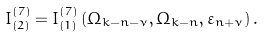<formula> <loc_0><loc_0><loc_500><loc_500>I _ { \left ( 2 \right ) } ^ { ( 7 ) } = I _ { \left ( 1 \right ) } ^ { ( 7 ) } \left ( \Omega _ { k - n - \nu } , \Omega _ { k - n } , \varepsilon _ { n + \nu } \right ) .</formula> 